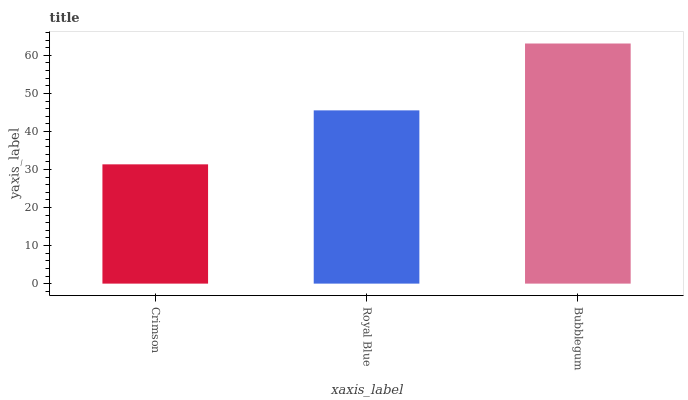Is Crimson the minimum?
Answer yes or no. Yes. Is Bubblegum the maximum?
Answer yes or no. Yes. Is Royal Blue the minimum?
Answer yes or no. No. Is Royal Blue the maximum?
Answer yes or no. No. Is Royal Blue greater than Crimson?
Answer yes or no. Yes. Is Crimson less than Royal Blue?
Answer yes or no. Yes. Is Crimson greater than Royal Blue?
Answer yes or no. No. Is Royal Blue less than Crimson?
Answer yes or no. No. Is Royal Blue the high median?
Answer yes or no. Yes. Is Royal Blue the low median?
Answer yes or no. Yes. Is Bubblegum the high median?
Answer yes or no. No. Is Bubblegum the low median?
Answer yes or no. No. 